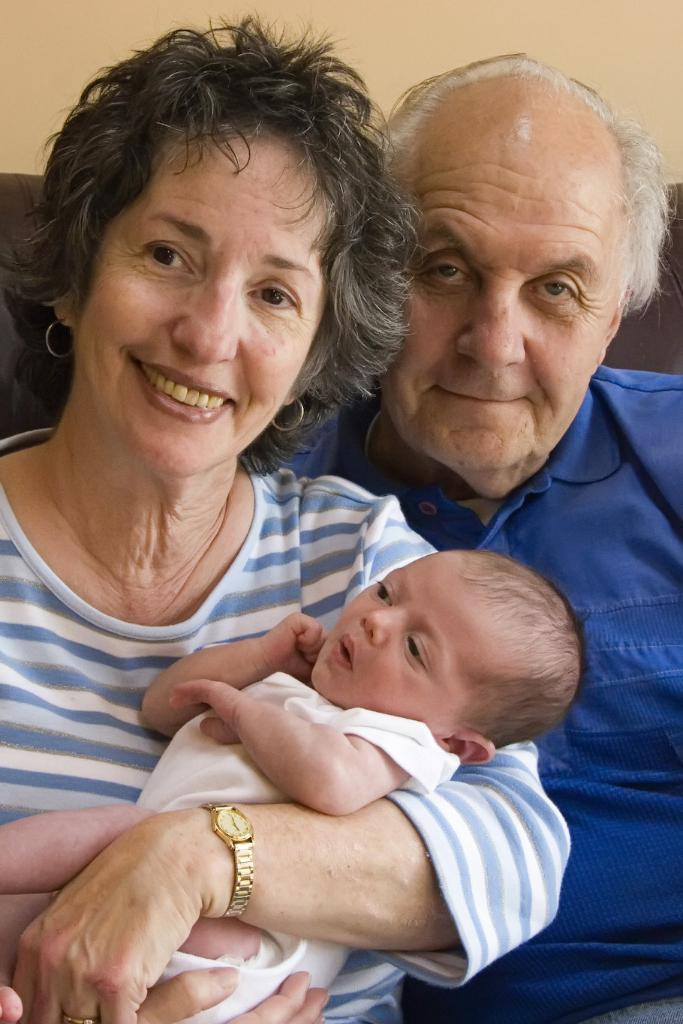What are the people in the image doing? The people in the image are sitting on a couch. Is there anyone holding a baby in the image? Yes, one of the people is holding a baby. What can be seen in the background of the image? There is a wall visible in the background of the image. How many crates are stacked next to the couch in the image? There are no crates present in the image. What type of frogs can be seen hopping around on the couch in the image? There are no frogs present in the image. 